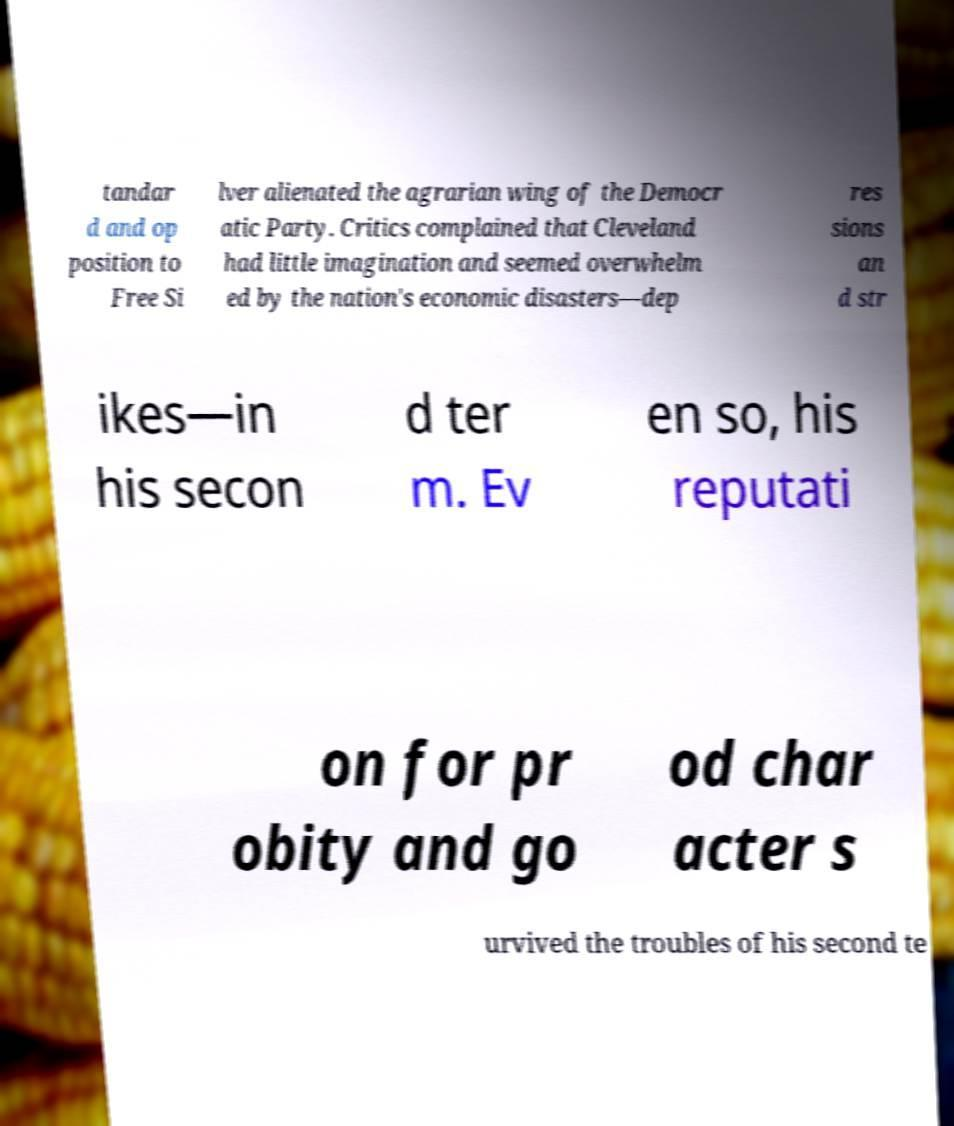Could you extract and type out the text from this image? tandar d and op position to Free Si lver alienated the agrarian wing of the Democr atic Party. Critics complained that Cleveland had little imagination and seemed overwhelm ed by the nation's economic disasters—dep res sions an d str ikes—in his secon d ter m. Ev en so, his reputati on for pr obity and go od char acter s urvived the troubles of his second te 